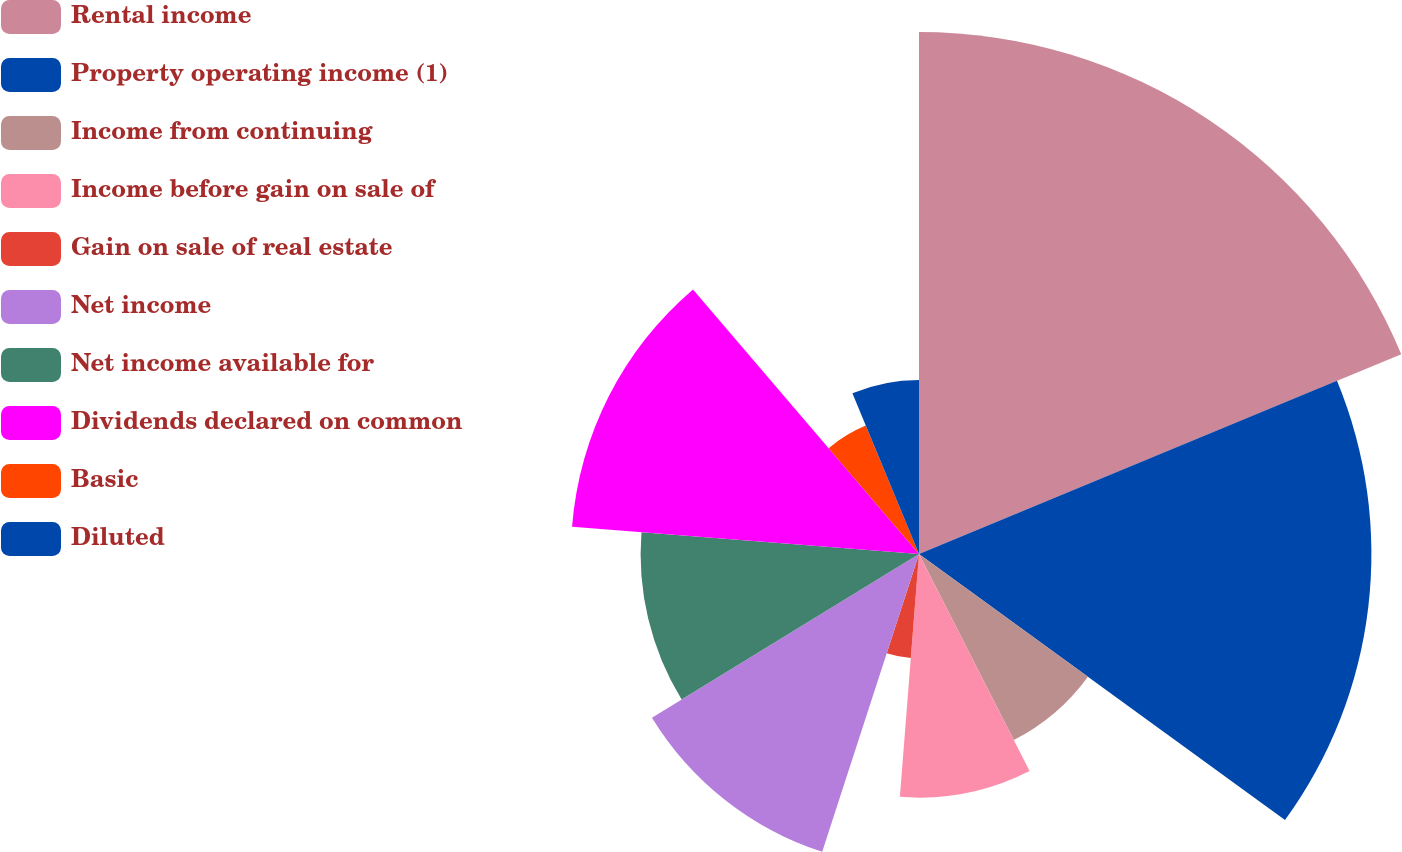Convert chart. <chart><loc_0><loc_0><loc_500><loc_500><pie_chart><fcel>Rental income<fcel>Property operating income (1)<fcel>Income from continuing<fcel>Income before gain on sale of<fcel>Gain on sale of real estate<fcel>Net income<fcel>Net income available for<fcel>Dividends declared on common<fcel>Basic<fcel>Diluted<nl><fcel>18.75%<fcel>16.25%<fcel>7.5%<fcel>8.75%<fcel>3.75%<fcel>11.25%<fcel>10.0%<fcel>12.5%<fcel>5.0%<fcel>6.25%<nl></chart> 